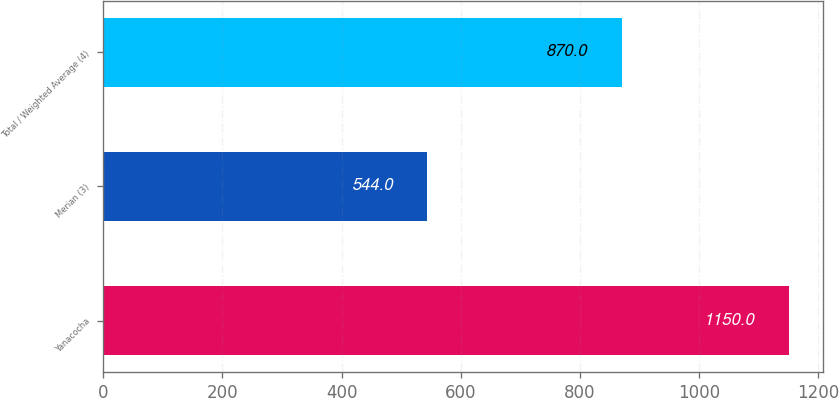Convert chart to OTSL. <chart><loc_0><loc_0><loc_500><loc_500><bar_chart><fcel>Yanacocha<fcel>Merian (3)<fcel>Total / Weighted Average (4)<nl><fcel>1150<fcel>544<fcel>870<nl></chart> 